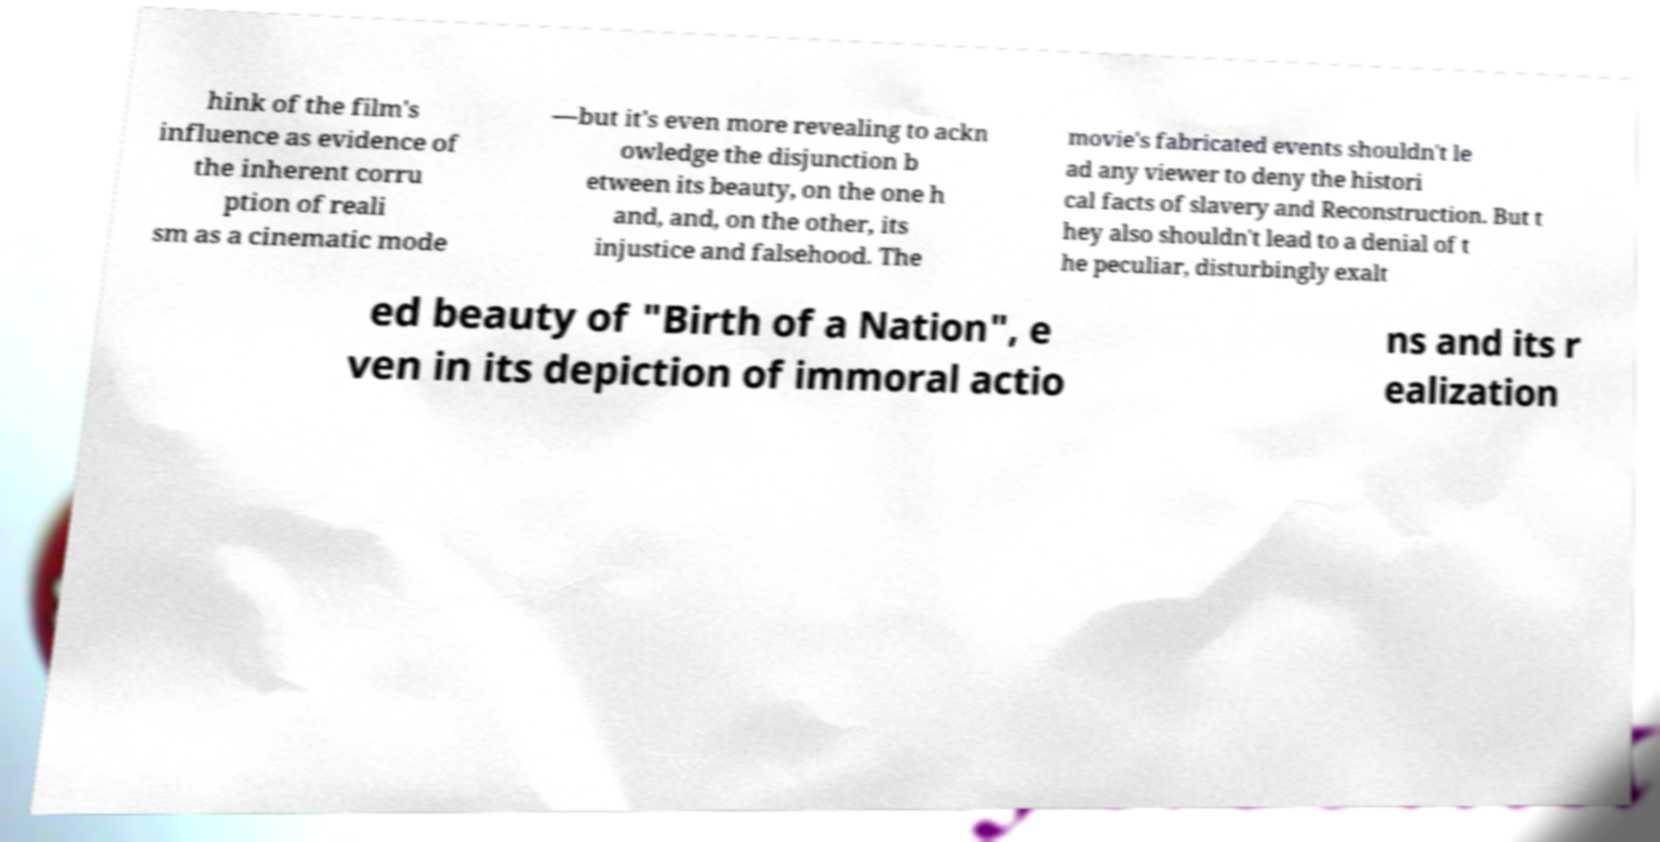Could you assist in decoding the text presented in this image and type it out clearly? hink of the film's influence as evidence of the inherent corru ption of reali sm as a cinematic mode —but it's even more revealing to ackn owledge the disjunction b etween its beauty, on the one h and, and, on the other, its injustice and falsehood. The movie's fabricated events shouldn't le ad any viewer to deny the histori cal facts of slavery and Reconstruction. But t hey also shouldn't lead to a denial of t he peculiar, disturbingly exalt ed beauty of "Birth of a Nation", e ven in its depiction of immoral actio ns and its r ealization 